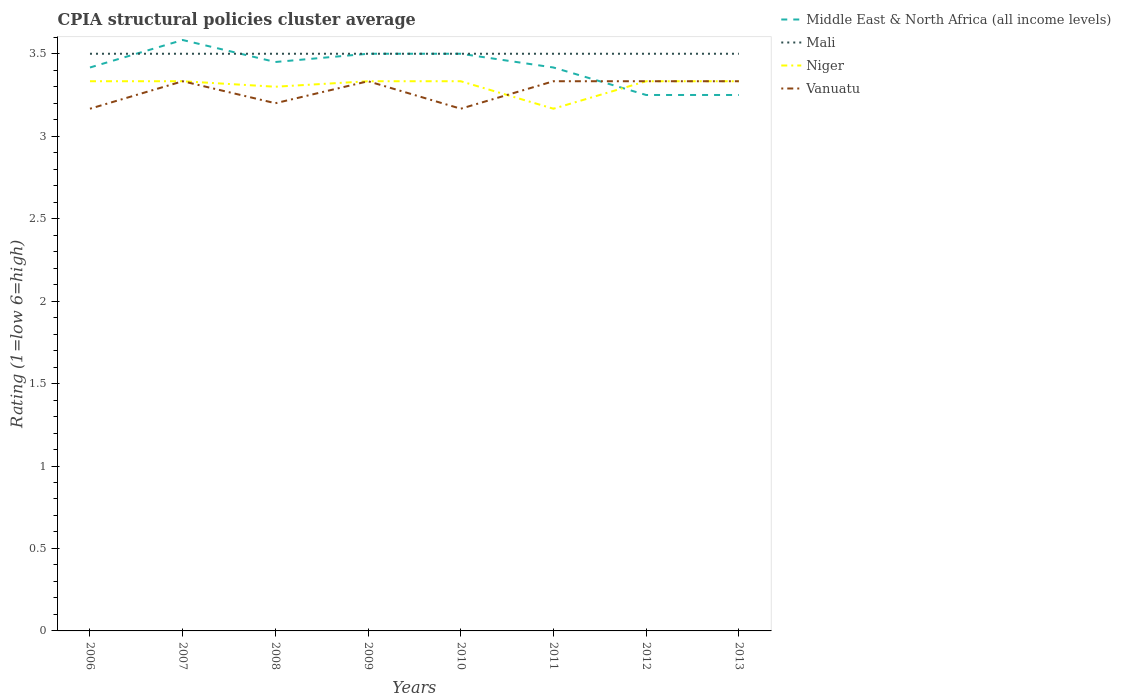How many different coloured lines are there?
Give a very brief answer. 4. Is the number of lines equal to the number of legend labels?
Make the answer very short. Yes. Across all years, what is the maximum CPIA rating in Mali?
Give a very brief answer. 3.5. What is the difference between the highest and the second highest CPIA rating in Mali?
Make the answer very short. 0. What is the difference between the highest and the lowest CPIA rating in Vanuatu?
Ensure brevity in your answer.  5. Is the CPIA rating in Niger strictly greater than the CPIA rating in Middle East & North Africa (all income levels) over the years?
Keep it short and to the point. No. How many years are there in the graph?
Provide a succinct answer. 8. What is the difference between two consecutive major ticks on the Y-axis?
Your answer should be compact. 0.5. Does the graph contain any zero values?
Provide a succinct answer. No. Where does the legend appear in the graph?
Your response must be concise. Top right. How are the legend labels stacked?
Make the answer very short. Vertical. What is the title of the graph?
Your response must be concise. CPIA structural policies cluster average. What is the label or title of the X-axis?
Provide a short and direct response. Years. What is the Rating (1=low 6=high) in Middle East & North Africa (all income levels) in 2006?
Offer a terse response. 3.42. What is the Rating (1=low 6=high) in Mali in 2006?
Give a very brief answer. 3.5. What is the Rating (1=low 6=high) in Niger in 2006?
Make the answer very short. 3.33. What is the Rating (1=low 6=high) in Vanuatu in 2006?
Your answer should be very brief. 3.17. What is the Rating (1=low 6=high) of Middle East & North Africa (all income levels) in 2007?
Offer a terse response. 3.58. What is the Rating (1=low 6=high) in Niger in 2007?
Your answer should be very brief. 3.33. What is the Rating (1=low 6=high) in Vanuatu in 2007?
Offer a very short reply. 3.33. What is the Rating (1=low 6=high) of Middle East & North Africa (all income levels) in 2008?
Provide a short and direct response. 3.45. What is the Rating (1=low 6=high) of Niger in 2009?
Offer a very short reply. 3.33. What is the Rating (1=low 6=high) in Vanuatu in 2009?
Your answer should be very brief. 3.33. What is the Rating (1=low 6=high) in Middle East & North Africa (all income levels) in 2010?
Give a very brief answer. 3.5. What is the Rating (1=low 6=high) of Niger in 2010?
Offer a terse response. 3.33. What is the Rating (1=low 6=high) of Vanuatu in 2010?
Provide a short and direct response. 3.17. What is the Rating (1=low 6=high) of Middle East & North Africa (all income levels) in 2011?
Your answer should be very brief. 3.42. What is the Rating (1=low 6=high) of Mali in 2011?
Ensure brevity in your answer.  3.5. What is the Rating (1=low 6=high) of Niger in 2011?
Your answer should be compact. 3.17. What is the Rating (1=low 6=high) of Vanuatu in 2011?
Make the answer very short. 3.33. What is the Rating (1=low 6=high) in Middle East & North Africa (all income levels) in 2012?
Your answer should be very brief. 3.25. What is the Rating (1=low 6=high) of Mali in 2012?
Ensure brevity in your answer.  3.5. What is the Rating (1=low 6=high) in Niger in 2012?
Your answer should be compact. 3.33. What is the Rating (1=low 6=high) in Vanuatu in 2012?
Your answer should be compact. 3.33. What is the Rating (1=low 6=high) in Middle East & North Africa (all income levels) in 2013?
Your answer should be very brief. 3.25. What is the Rating (1=low 6=high) in Niger in 2013?
Ensure brevity in your answer.  3.33. What is the Rating (1=low 6=high) of Vanuatu in 2013?
Keep it short and to the point. 3.33. Across all years, what is the maximum Rating (1=low 6=high) in Middle East & North Africa (all income levels)?
Ensure brevity in your answer.  3.58. Across all years, what is the maximum Rating (1=low 6=high) in Mali?
Your response must be concise. 3.5. Across all years, what is the maximum Rating (1=low 6=high) of Niger?
Give a very brief answer. 3.33. Across all years, what is the maximum Rating (1=low 6=high) of Vanuatu?
Ensure brevity in your answer.  3.33. Across all years, what is the minimum Rating (1=low 6=high) of Niger?
Make the answer very short. 3.17. Across all years, what is the minimum Rating (1=low 6=high) of Vanuatu?
Offer a very short reply. 3.17. What is the total Rating (1=low 6=high) of Middle East & North Africa (all income levels) in the graph?
Provide a succinct answer. 27.37. What is the total Rating (1=low 6=high) of Mali in the graph?
Your answer should be compact. 28. What is the total Rating (1=low 6=high) of Niger in the graph?
Your answer should be very brief. 26.47. What is the total Rating (1=low 6=high) in Vanuatu in the graph?
Keep it short and to the point. 26.2. What is the difference between the Rating (1=low 6=high) of Mali in 2006 and that in 2007?
Your answer should be very brief. 0. What is the difference between the Rating (1=low 6=high) in Niger in 2006 and that in 2007?
Offer a terse response. 0. What is the difference between the Rating (1=low 6=high) of Middle East & North Africa (all income levels) in 2006 and that in 2008?
Offer a terse response. -0.03. What is the difference between the Rating (1=low 6=high) in Mali in 2006 and that in 2008?
Your answer should be compact. 0. What is the difference between the Rating (1=low 6=high) in Vanuatu in 2006 and that in 2008?
Offer a very short reply. -0.03. What is the difference between the Rating (1=low 6=high) of Middle East & North Africa (all income levels) in 2006 and that in 2009?
Offer a terse response. -0.08. What is the difference between the Rating (1=low 6=high) in Mali in 2006 and that in 2009?
Provide a succinct answer. 0. What is the difference between the Rating (1=low 6=high) of Niger in 2006 and that in 2009?
Offer a terse response. 0. What is the difference between the Rating (1=low 6=high) in Middle East & North Africa (all income levels) in 2006 and that in 2010?
Offer a terse response. -0.08. What is the difference between the Rating (1=low 6=high) in Niger in 2006 and that in 2010?
Provide a short and direct response. 0. What is the difference between the Rating (1=low 6=high) of Middle East & North Africa (all income levels) in 2006 and that in 2011?
Make the answer very short. 0. What is the difference between the Rating (1=low 6=high) in Mali in 2006 and that in 2011?
Provide a succinct answer. 0. What is the difference between the Rating (1=low 6=high) of Middle East & North Africa (all income levels) in 2006 and that in 2012?
Your answer should be compact. 0.17. What is the difference between the Rating (1=low 6=high) in Niger in 2006 and that in 2013?
Provide a succinct answer. 0. What is the difference between the Rating (1=low 6=high) in Vanuatu in 2006 and that in 2013?
Offer a terse response. -0.17. What is the difference between the Rating (1=low 6=high) of Middle East & North Africa (all income levels) in 2007 and that in 2008?
Your response must be concise. 0.13. What is the difference between the Rating (1=low 6=high) in Vanuatu in 2007 and that in 2008?
Ensure brevity in your answer.  0.13. What is the difference between the Rating (1=low 6=high) in Middle East & North Africa (all income levels) in 2007 and that in 2009?
Give a very brief answer. 0.08. What is the difference between the Rating (1=low 6=high) of Mali in 2007 and that in 2009?
Provide a short and direct response. 0. What is the difference between the Rating (1=low 6=high) of Middle East & North Africa (all income levels) in 2007 and that in 2010?
Provide a short and direct response. 0.08. What is the difference between the Rating (1=low 6=high) in Vanuatu in 2007 and that in 2010?
Give a very brief answer. 0.17. What is the difference between the Rating (1=low 6=high) of Mali in 2007 and that in 2011?
Offer a terse response. 0. What is the difference between the Rating (1=low 6=high) of Vanuatu in 2007 and that in 2011?
Your answer should be very brief. 0. What is the difference between the Rating (1=low 6=high) in Vanuatu in 2007 and that in 2012?
Make the answer very short. 0. What is the difference between the Rating (1=low 6=high) in Mali in 2007 and that in 2013?
Ensure brevity in your answer.  0. What is the difference between the Rating (1=low 6=high) in Mali in 2008 and that in 2009?
Provide a short and direct response. 0. What is the difference between the Rating (1=low 6=high) in Niger in 2008 and that in 2009?
Provide a short and direct response. -0.03. What is the difference between the Rating (1=low 6=high) in Vanuatu in 2008 and that in 2009?
Give a very brief answer. -0.13. What is the difference between the Rating (1=low 6=high) of Middle East & North Africa (all income levels) in 2008 and that in 2010?
Offer a very short reply. -0.05. What is the difference between the Rating (1=low 6=high) of Niger in 2008 and that in 2010?
Provide a short and direct response. -0.03. What is the difference between the Rating (1=low 6=high) of Vanuatu in 2008 and that in 2010?
Provide a short and direct response. 0.03. What is the difference between the Rating (1=low 6=high) in Niger in 2008 and that in 2011?
Offer a terse response. 0.13. What is the difference between the Rating (1=low 6=high) of Vanuatu in 2008 and that in 2011?
Provide a succinct answer. -0.13. What is the difference between the Rating (1=low 6=high) in Niger in 2008 and that in 2012?
Your response must be concise. -0.03. What is the difference between the Rating (1=low 6=high) of Vanuatu in 2008 and that in 2012?
Make the answer very short. -0.13. What is the difference between the Rating (1=low 6=high) of Middle East & North Africa (all income levels) in 2008 and that in 2013?
Give a very brief answer. 0.2. What is the difference between the Rating (1=low 6=high) in Niger in 2008 and that in 2013?
Your answer should be very brief. -0.03. What is the difference between the Rating (1=low 6=high) in Vanuatu in 2008 and that in 2013?
Provide a short and direct response. -0.13. What is the difference between the Rating (1=low 6=high) of Middle East & North Africa (all income levels) in 2009 and that in 2010?
Offer a terse response. 0. What is the difference between the Rating (1=low 6=high) in Vanuatu in 2009 and that in 2010?
Give a very brief answer. 0.17. What is the difference between the Rating (1=low 6=high) of Middle East & North Africa (all income levels) in 2009 and that in 2011?
Provide a succinct answer. 0.08. What is the difference between the Rating (1=low 6=high) in Niger in 2009 and that in 2011?
Offer a very short reply. 0.17. What is the difference between the Rating (1=low 6=high) of Niger in 2009 and that in 2012?
Offer a terse response. 0. What is the difference between the Rating (1=low 6=high) of Mali in 2009 and that in 2013?
Keep it short and to the point. 0. What is the difference between the Rating (1=low 6=high) in Niger in 2009 and that in 2013?
Your answer should be very brief. 0. What is the difference between the Rating (1=low 6=high) in Middle East & North Africa (all income levels) in 2010 and that in 2011?
Make the answer very short. 0.08. What is the difference between the Rating (1=low 6=high) of Middle East & North Africa (all income levels) in 2010 and that in 2012?
Your answer should be compact. 0.25. What is the difference between the Rating (1=low 6=high) of Vanuatu in 2010 and that in 2012?
Your response must be concise. -0.17. What is the difference between the Rating (1=low 6=high) in Mali in 2010 and that in 2013?
Keep it short and to the point. 0. What is the difference between the Rating (1=low 6=high) in Niger in 2010 and that in 2013?
Make the answer very short. 0. What is the difference between the Rating (1=low 6=high) of Vanuatu in 2010 and that in 2013?
Make the answer very short. -0.17. What is the difference between the Rating (1=low 6=high) in Middle East & North Africa (all income levels) in 2011 and that in 2012?
Your response must be concise. 0.17. What is the difference between the Rating (1=low 6=high) of Niger in 2011 and that in 2012?
Provide a succinct answer. -0.17. What is the difference between the Rating (1=low 6=high) of Middle East & North Africa (all income levels) in 2011 and that in 2013?
Your response must be concise. 0.17. What is the difference between the Rating (1=low 6=high) in Mali in 2011 and that in 2013?
Make the answer very short. 0. What is the difference between the Rating (1=low 6=high) of Niger in 2011 and that in 2013?
Your answer should be compact. -0.17. What is the difference between the Rating (1=low 6=high) in Vanuatu in 2011 and that in 2013?
Ensure brevity in your answer.  0. What is the difference between the Rating (1=low 6=high) of Vanuatu in 2012 and that in 2013?
Make the answer very short. 0. What is the difference between the Rating (1=low 6=high) of Middle East & North Africa (all income levels) in 2006 and the Rating (1=low 6=high) of Mali in 2007?
Provide a succinct answer. -0.08. What is the difference between the Rating (1=low 6=high) of Middle East & North Africa (all income levels) in 2006 and the Rating (1=low 6=high) of Niger in 2007?
Give a very brief answer. 0.08. What is the difference between the Rating (1=low 6=high) of Middle East & North Africa (all income levels) in 2006 and the Rating (1=low 6=high) of Vanuatu in 2007?
Your response must be concise. 0.08. What is the difference between the Rating (1=low 6=high) of Middle East & North Africa (all income levels) in 2006 and the Rating (1=low 6=high) of Mali in 2008?
Keep it short and to the point. -0.08. What is the difference between the Rating (1=low 6=high) of Middle East & North Africa (all income levels) in 2006 and the Rating (1=low 6=high) of Niger in 2008?
Offer a terse response. 0.12. What is the difference between the Rating (1=low 6=high) in Middle East & North Africa (all income levels) in 2006 and the Rating (1=low 6=high) in Vanuatu in 2008?
Ensure brevity in your answer.  0.22. What is the difference between the Rating (1=low 6=high) in Mali in 2006 and the Rating (1=low 6=high) in Niger in 2008?
Make the answer very short. 0.2. What is the difference between the Rating (1=low 6=high) of Mali in 2006 and the Rating (1=low 6=high) of Vanuatu in 2008?
Keep it short and to the point. 0.3. What is the difference between the Rating (1=low 6=high) of Niger in 2006 and the Rating (1=low 6=high) of Vanuatu in 2008?
Keep it short and to the point. 0.13. What is the difference between the Rating (1=low 6=high) in Middle East & North Africa (all income levels) in 2006 and the Rating (1=low 6=high) in Mali in 2009?
Your answer should be very brief. -0.08. What is the difference between the Rating (1=low 6=high) of Middle East & North Africa (all income levels) in 2006 and the Rating (1=low 6=high) of Niger in 2009?
Provide a short and direct response. 0.08. What is the difference between the Rating (1=low 6=high) of Middle East & North Africa (all income levels) in 2006 and the Rating (1=low 6=high) of Vanuatu in 2009?
Your answer should be very brief. 0.08. What is the difference between the Rating (1=low 6=high) of Mali in 2006 and the Rating (1=low 6=high) of Niger in 2009?
Provide a succinct answer. 0.17. What is the difference between the Rating (1=low 6=high) in Middle East & North Africa (all income levels) in 2006 and the Rating (1=low 6=high) in Mali in 2010?
Offer a terse response. -0.08. What is the difference between the Rating (1=low 6=high) in Middle East & North Africa (all income levels) in 2006 and the Rating (1=low 6=high) in Niger in 2010?
Ensure brevity in your answer.  0.08. What is the difference between the Rating (1=low 6=high) in Mali in 2006 and the Rating (1=low 6=high) in Niger in 2010?
Ensure brevity in your answer.  0.17. What is the difference between the Rating (1=low 6=high) in Mali in 2006 and the Rating (1=low 6=high) in Vanuatu in 2010?
Keep it short and to the point. 0.33. What is the difference between the Rating (1=low 6=high) of Middle East & North Africa (all income levels) in 2006 and the Rating (1=low 6=high) of Mali in 2011?
Offer a terse response. -0.08. What is the difference between the Rating (1=low 6=high) of Middle East & North Africa (all income levels) in 2006 and the Rating (1=low 6=high) of Niger in 2011?
Give a very brief answer. 0.25. What is the difference between the Rating (1=low 6=high) of Middle East & North Africa (all income levels) in 2006 and the Rating (1=low 6=high) of Vanuatu in 2011?
Offer a very short reply. 0.08. What is the difference between the Rating (1=low 6=high) in Mali in 2006 and the Rating (1=low 6=high) in Vanuatu in 2011?
Make the answer very short. 0.17. What is the difference between the Rating (1=low 6=high) of Niger in 2006 and the Rating (1=low 6=high) of Vanuatu in 2011?
Your answer should be very brief. 0. What is the difference between the Rating (1=low 6=high) in Middle East & North Africa (all income levels) in 2006 and the Rating (1=low 6=high) in Mali in 2012?
Provide a short and direct response. -0.08. What is the difference between the Rating (1=low 6=high) of Middle East & North Africa (all income levels) in 2006 and the Rating (1=low 6=high) of Niger in 2012?
Your answer should be compact. 0.08. What is the difference between the Rating (1=low 6=high) in Middle East & North Africa (all income levels) in 2006 and the Rating (1=low 6=high) in Vanuatu in 2012?
Your answer should be compact. 0.08. What is the difference between the Rating (1=low 6=high) in Mali in 2006 and the Rating (1=low 6=high) in Niger in 2012?
Make the answer very short. 0.17. What is the difference between the Rating (1=low 6=high) in Mali in 2006 and the Rating (1=low 6=high) in Vanuatu in 2012?
Offer a very short reply. 0.17. What is the difference between the Rating (1=low 6=high) in Niger in 2006 and the Rating (1=low 6=high) in Vanuatu in 2012?
Provide a short and direct response. 0. What is the difference between the Rating (1=low 6=high) of Middle East & North Africa (all income levels) in 2006 and the Rating (1=low 6=high) of Mali in 2013?
Your response must be concise. -0.08. What is the difference between the Rating (1=low 6=high) in Middle East & North Africa (all income levels) in 2006 and the Rating (1=low 6=high) in Niger in 2013?
Your response must be concise. 0.08. What is the difference between the Rating (1=low 6=high) in Middle East & North Africa (all income levels) in 2006 and the Rating (1=low 6=high) in Vanuatu in 2013?
Provide a short and direct response. 0.08. What is the difference between the Rating (1=low 6=high) in Niger in 2006 and the Rating (1=low 6=high) in Vanuatu in 2013?
Make the answer very short. 0. What is the difference between the Rating (1=low 6=high) of Middle East & North Africa (all income levels) in 2007 and the Rating (1=low 6=high) of Mali in 2008?
Keep it short and to the point. 0.08. What is the difference between the Rating (1=low 6=high) in Middle East & North Africa (all income levels) in 2007 and the Rating (1=low 6=high) in Niger in 2008?
Provide a succinct answer. 0.28. What is the difference between the Rating (1=low 6=high) of Middle East & North Africa (all income levels) in 2007 and the Rating (1=low 6=high) of Vanuatu in 2008?
Provide a short and direct response. 0.38. What is the difference between the Rating (1=low 6=high) of Mali in 2007 and the Rating (1=low 6=high) of Niger in 2008?
Your answer should be compact. 0.2. What is the difference between the Rating (1=low 6=high) of Niger in 2007 and the Rating (1=low 6=high) of Vanuatu in 2008?
Your answer should be compact. 0.13. What is the difference between the Rating (1=low 6=high) in Middle East & North Africa (all income levels) in 2007 and the Rating (1=low 6=high) in Mali in 2009?
Ensure brevity in your answer.  0.08. What is the difference between the Rating (1=low 6=high) in Niger in 2007 and the Rating (1=low 6=high) in Vanuatu in 2009?
Keep it short and to the point. 0. What is the difference between the Rating (1=low 6=high) in Middle East & North Africa (all income levels) in 2007 and the Rating (1=low 6=high) in Mali in 2010?
Make the answer very short. 0.08. What is the difference between the Rating (1=low 6=high) of Middle East & North Africa (all income levels) in 2007 and the Rating (1=low 6=high) of Vanuatu in 2010?
Keep it short and to the point. 0.42. What is the difference between the Rating (1=low 6=high) in Mali in 2007 and the Rating (1=low 6=high) in Niger in 2010?
Your answer should be very brief. 0.17. What is the difference between the Rating (1=low 6=high) of Mali in 2007 and the Rating (1=low 6=high) of Vanuatu in 2010?
Offer a very short reply. 0.33. What is the difference between the Rating (1=low 6=high) of Niger in 2007 and the Rating (1=low 6=high) of Vanuatu in 2010?
Your answer should be very brief. 0.17. What is the difference between the Rating (1=low 6=high) of Middle East & North Africa (all income levels) in 2007 and the Rating (1=low 6=high) of Mali in 2011?
Keep it short and to the point. 0.08. What is the difference between the Rating (1=low 6=high) in Middle East & North Africa (all income levels) in 2007 and the Rating (1=low 6=high) in Niger in 2011?
Your answer should be very brief. 0.42. What is the difference between the Rating (1=low 6=high) of Mali in 2007 and the Rating (1=low 6=high) of Niger in 2011?
Your answer should be compact. 0.33. What is the difference between the Rating (1=low 6=high) of Niger in 2007 and the Rating (1=low 6=high) of Vanuatu in 2011?
Make the answer very short. 0. What is the difference between the Rating (1=low 6=high) of Middle East & North Africa (all income levels) in 2007 and the Rating (1=low 6=high) of Mali in 2012?
Your response must be concise. 0.08. What is the difference between the Rating (1=low 6=high) of Mali in 2007 and the Rating (1=low 6=high) of Vanuatu in 2012?
Provide a succinct answer. 0.17. What is the difference between the Rating (1=low 6=high) in Niger in 2007 and the Rating (1=low 6=high) in Vanuatu in 2012?
Provide a short and direct response. 0. What is the difference between the Rating (1=low 6=high) of Middle East & North Africa (all income levels) in 2007 and the Rating (1=low 6=high) of Mali in 2013?
Your answer should be very brief. 0.08. What is the difference between the Rating (1=low 6=high) in Middle East & North Africa (all income levels) in 2007 and the Rating (1=low 6=high) in Vanuatu in 2013?
Offer a very short reply. 0.25. What is the difference between the Rating (1=low 6=high) in Mali in 2007 and the Rating (1=low 6=high) in Vanuatu in 2013?
Make the answer very short. 0.17. What is the difference between the Rating (1=low 6=high) of Niger in 2007 and the Rating (1=low 6=high) of Vanuatu in 2013?
Make the answer very short. 0. What is the difference between the Rating (1=low 6=high) in Middle East & North Africa (all income levels) in 2008 and the Rating (1=low 6=high) in Niger in 2009?
Make the answer very short. 0.12. What is the difference between the Rating (1=low 6=high) in Middle East & North Africa (all income levels) in 2008 and the Rating (1=low 6=high) in Vanuatu in 2009?
Keep it short and to the point. 0.12. What is the difference between the Rating (1=low 6=high) in Niger in 2008 and the Rating (1=low 6=high) in Vanuatu in 2009?
Make the answer very short. -0.03. What is the difference between the Rating (1=low 6=high) in Middle East & North Africa (all income levels) in 2008 and the Rating (1=low 6=high) in Mali in 2010?
Give a very brief answer. -0.05. What is the difference between the Rating (1=low 6=high) in Middle East & North Africa (all income levels) in 2008 and the Rating (1=low 6=high) in Niger in 2010?
Make the answer very short. 0.12. What is the difference between the Rating (1=low 6=high) of Middle East & North Africa (all income levels) in 2008 and the Rating (1=low 6=high) of Vanuatu in 2010?
Provide a succinct answer. 0.28. What is the difference between the Rating (1=low 6=high) of Niger in 2008 and the Rating (1=low 6=high) of Vanuatu in 2010?
Offer a very short reply. 0.13. What is the difference between the Rating (1=low 6=high) of Middle East & North Africa (all income levels) in 2008 and the Rating (1=low 6=high) of Mali in 2011?
Your answer should be very brief. -0.05. What is the difference between the Rating (1=low 6=high) in Middle East & North Africa (all income levels) in 2008 and the Rating (1=low 6=high) in Niger in 2011?
Provide a short and direct response. 0.28. What is the difference between the Rating (1=low 6=high) in Middle East & North Africa (all income levels) in 2008 and the Rating (1=low 6=high) in Vanuatu in 2011?
Your response must be concise. 0.12. What is the difference between the Rating (1=low 6=high) in Mali in 2008 and the Rating (1=low 6=high) in Niger in 2011?
Ensure brevity in your answer.  0.33. What is the difference between the Rating (1=low 6=high) of Niger in 2008 and the Rating (1=low 6=high) of Vanuatu in 2011?
Provide a succinct answer. -0.03. What is the difference between the Rating (1=low 6=high) of Middle East & North Africa (all income levels) in 2008 and the Rating (1=low 6=high) of Niger in 2012?
Your answer should be very brief. 0.12. What is the difference between the Rating (1=low 6=high) in Middle East & North Africa (all income levels) in 2008 and the Rating (1=low 6=high) in Vanuatu in 2012?
Ensure brevity in your answer.  0.12. What is the difference between the Rating (1=low 6=high) in Mali in 2008 and the Rating (1=low 6=high) in Niger in 2012?
Ensure brevity in your answer.  0.17. What is the difference between the Rating (1=low 6=high) of Mali in 2008 and the Rating (1=low 6=high) of Vanuatu in 2012?
Keep it short and to the point. 0.17. What is the difference between the Rating (1=low 6=high) in Niger in 2008 and the Rating (1=low 6=high) in Vanuatu in 2012?
Your answer should be very brief. -0.03. What is the difference between the Rating (1=low 6=high) in Middle East & North Africa (all income levels) in 2008 and the Rating (1=low 6=high) in Mali in 2013?
Offer a terse response. -0.05. What is the difference between the Rating (1=low 6=high) in Middle East & North Africa (all income levels) in 2008 and the Rating (1=low 6=high) in Niger in 2013?
Ensure brevity in your answer.  0.12. What is the difference between the Rating (1=low 6=high) of Middle East & North Africa (all income levels) in 2008 and the Rating (1=low 6=high) of Vanuatu in 2013?
Make the answer very short. 0.12. What is the difference between the Rating (1=low 6=high) of Niger in 2008 and the Rating (1=low 6=high) of Vanuatu in 2013?
Offer a terse response. -0.03. What is the difference between the Rating (1=low 6=high) in Mali in 2009 and the Rating (1=low 6=high) in Vanuatu in 2010?
Keep it short and to the point. 0.33. What is the difference between the Rating (1=low 6=high) of Middle East & North Africa (all income levels) in 2009 and the Rating (1=low 6=high) of Mali in 2011?
Offer a terse response. 0. What is the difference between the Rating (1=low 6=high) in Middle East & North Africa (all income levels) in 2009 and the Rating (1=low 6=high) in Vanuatu in 2011?
Ensure brevity in your answer.  0.17. What is the difference between the Rating (1=low 6=high) in Mali in 2009 and the Rating (1=low 6=high) in Vanuatu in 2011?
Make the answer very short. 0.17. What is the difference between the Rating (1=low 6=high) in Niger in 2009 and the Rating (1=low 6=high) in Vanuatu in 2011?
Give a very brief answer. 0. What is the difference between the Rating (1=low 6=high) of Middle East & North Africa (all income levels) in 2009 and the Rating (1=low 6=high) of Mali in 2012?
Your response must be concise. 0. What is the difference between the Rating (1=low 6=high) of Middle East & North Africa (all income levels) in 2009 and the Rating (1=low 6=high) of Vanuatu in 2012?
Offer a very short reply. 0.17. What is the difference between the Rating (1=low 6=high) in Mali in 2009 and the Rating (1=low 6=high) in Niger in 2012?
Provide a short and direct response. 0.17. What is the difference between the Rating (1=low 6=high) in Middle East & North Africa (all income levels) in 2009 and the Rating (1=low 6=high) in Vanuatu in 2013?
Provide a short and direct response. 0.17. What is the difference between the Rating (1=low 6=high) of Mali in 2009 and the Rating (1=low 6=high) of Niger in 2013?
Provide a short and direct response. 0.17. What is the difference between the Rating (1=low 6=high) of Middle East & North Africa (all income levels) in 2010 and the Rating (1=low 6=high) of Niger in 2011?
Provide a succinct answer. 0.33. What is the difference between the Rating (1=low 6=high) of Middle East & North Africa (all income levels) in 2010 and the Rating (1=low 6=high) of Vanuatu in 2011?
Provide a short and direct response. 0.17. What is the difference between the Rating (1=low 6=high) in Mali in 2010 and the Rating (1=low 6=high) in Vanuatu in 2011?
Provide a short and direct response. 0.17. What is the difference between the Rating (1=low 6=high) of Middle East & North Africa (all income levels) in 2010 and the Rating (1=low 6=high) of Mali in 2012?
Keep it short and to the point. 0. What is the difference between the Rating (1=low 6=high) in Niger in 2010 and the Rating (1=low 6=high) in Vanuatu in 2012?
Ensure brevity in your answer.  0. What is the difference between the Rating (1=low 6=high) in Middle East & North Africa (all income levels) in 2010 and the Rating (1=low 6=high) in Niger in 2013?
Ensure brevity in your answer.  0.17. What is the difference between the Rating (1=low 6=high) in Middle East & North Africa (all income levels) in 2010 and the Rating (1=low 6=high) in Vanuatu in 2013?
Offer a terse response. 0.17. What is the difference between the Rating (1=low 6=high) in Mali in 2010 and the Rating (1=low 6=high) in Niger in 2013?
Provide a succinct answer. 0.17. What is the difference between the Rating (1=low 6=high) of Mali in 2010 and the Rating (1=low 6=high) of Vanuatu in 2013?
Your response must be concise. 0.17. What is the difference between the Rating (1=low 6=high) in Middle East & North Africa (all income levels) in 2011 and the Rating (1=low 6=high) in Mali in 2012?
Offer a terse response. -0.08. What is the difference between the Rating (1=low 6=high) of Middle East & North Africa (all income levels) in 2011 and the Rating (1=low 6=high) of Niger in 2012?
Your response must be concise. 0.08. What is the difference between the Rating (1=low 6=high) in Middle East & North Africa (all income levels) in 2011 and the Rating (1=low 6=high) in Vanuatu in 2012?
Give a very brief answer. 0.08. What is the difference between the Rating (1=low 6=high) in Mali in 2011 and the Rating (1=low 6=high) in Niger in 2012?
Provide a short and direct response. 0.17. What is the difference between the Rating (1=low 6=high) of Niger in 2011 and the Rating (1=low 6=high) of Vanuatu in 2012?
Keep it short and to the point. -0.17. What is the difference between the Rating (1=low 6=high) in Middle East & North Africa (all income levels) in 2011 and the Rating (1=low 6=high) in Mali in 2013?
Provide a succinct answer. -0.08. What is the difference between the Rating (1=low 6=high) of Middle East & North Africa (all income levels) in 2011 and the Rating (1=low 6=high) of Niger in 2013?
Your answer should be compact. 0.08. What is the difference between the Rating (1=low 6=high) in Middle East & North Africa (all income levels) in 2011 and the Rating (1=low 6=high) in Vanuatu in 2013?
Offer a terse response. 0.08. What is the difference between the Rating (1=low 6=high) in Mali in 2011 and the Rating (1=low 6=high) in Niger in 2013?
Provide a short and direct response. 0.17. What is the difference between the Rating (1=low 6=high) in Niger in 2011 and the Rating (1=low 6=high) in Vanuatu in 2013?
Your response must be concise. -0.17. What is the difference between the Rating (1=low 6=high) of Middle East & North Africa (all income levels) in 2012 and the Rating (1=low 6=high) of Niger in 2013?
Give a very brief answer. -0.08. What is the difference between the Rating (1=low 6=high) of Middle East & North Africa (all income levels) in 2012 and the Rating (1=low 6=high) of Vanuatu in 2013?
Your answer should be compact. -0.08. What is the average Rating (1=low 6=high) of Middle East & North Africa (all income levels) per year?
Offer a very short reply. 3.42. What is the average Rating (1=low 6=high) in Mali per year?
Keep it short and to the point. 3.5. What is the average Rating (1=low 6=high) of Niger per year?
Your answer should be very brief. 3.31. What is the average Rating (1=low 6=high) of Vanuatu per year?
Offer a terse response. 3.27. In the year 2006, what is the difference between the Rating (1=low 6=high) in Middle East & North Africa (all income levels) and Rating (1=low 6=high) in Mali?
Provide a short and direct response. -0.08. In the year 2006, what is the difference between the Rating (1=low 6=high) of Middle East & North Africa (all income levels) and Rating (1=low 6=high) of Niger?
Provide a succinct answer. 0.08. In the year 2006, what is the difference between the Rating (1=low 6=high) in Niger and Rating (1=low 6=high) in Vanuatu?
Your answer should be very brief. 0.17. In the year 2007, what is the difference between the Rating (1=low 6=high) of Middle East & North Africa (all income levels) and Rating (1=low 6=high) of Mali?
Keep it short and to the point. 0.08. In the year 2008, what is the difference between the Rating (1=low 6=high) in Middle East & North Africa (all income levels) and Rating (1=low 6=high) in Niger?
Your answer should be very brief. 0.15. In the year 2008, what is the difference between the Rating (1=low 6=high) of Middle East & North Africa (all income levels) and Rating (1=low 6=high) of Vanuatu?
Offer a very short reply. 0.25. In the year 2008, what is the difference between the Rating (1=low 6=high) in Mali and Rating (1=low 6=high) in Vanuatu?
Your answer should be compact. 0.3. In the year 2008, what is the difference between the Rating (1=low 6=high) in Niger and Rating (1=low 6=high) in Vanuatu?
Make the answer very short. 0.1. In the year 2009, what is the difference between the Rating (1=low 6=high) of Middle East & North Africa (all income levels) and Rating (1=low 6=high) of Vanuatu?
Ensure brevity in your answer.  0.17. In the year 2009, what is the difference between the Rating (1=low 6=high) of Niger and Rating (1=low 6=high) of Vanuatu?
Provide a short and direct response. 0. In the year 2010, what is the difference between the Rating (1=low 6=high) in Niger and Rating (1=low 6=high) in Vanuatu?
Offer a very short reply. 0.17. In the year 2011, what is the difference between the Rating (1=low 6=high) of Middle East & North Africa (all income levels) and Rating (1=low 6=high) of Mali?
Your answer should be compact. -0.08. In the year 2011, what is the difference between the Rating (1=low 6=high) in Middle East & North Africa (all income levels) and Rating (1=low 6=high) in Vanuatu?
Your response must be concise. 0.08. In the year 2011, what is the difference between the Rating (1=low 6=high) of Mali and Rating (1=low 6=high) of Niger?
Your response must be concise. 0.33. In the year 2011, what is the difference between the Rating (1=low 6=high) in Mali and Rating (1=low 6=high) in Vanuatu?
Provide a succinct answer. 0.17. In the year 2011, what is the difference between the Rating (1=low 6=high) of Niger and Rating (1=low 6=high) of Vanuatu?
Provide a succinct answer. -0.17. In the year 2012, what is the difference between the Rating (1=low 6=high) of Middle East & North Africa (all income levels) and Rating (1=low 6=high) of Niger?
Offer a very short reply. -0.08. In the year 2012, what is the difference between the Rating (1=low 6=high) in Middle East & North Africa (all income levels) and Rating (1=low 6=high) in Vanuatu?
Offer a very short reply. -0.08. In the year 2012, what is the difference between the Rating (1=low 6=high) in Mali and Rating (1=low 6=high) in Niger?
Give a very brief answer. 0.17. In the year 2013, what is the difference between the Rating (1=low 6=high) of Middle East & North Africa (all income levels) and Rating (1=low 6=high) of Niger?
Provide a short and direct response. -0.08. In the year 2013, what is the difference between the Rating (1=low 6=high) of Middle East & North Africa (all income levels) and Rating (1=low 6=high) of Vanuatu?
Your response must be concise. -0.08. In the year 2013, what is the difference between the Rating (1=low 6=high) of Mali and Rating (1=low 6=high) of Niger?
Keep it short and to the point. 0.17. In the year 2013, what is the difference between the Rating (1=low 6=high) of Mali and Rating (1=low 6=high) of Vanuatu?
Your answer should be compact. 0.17. What is the ratio of the Rating (1=low 6=high) in Middle East & North Africa (all income levels) in 2006 to that in 2007?
Ensure brevity in your answer.  0.95. What is the ratio of the Rating (1=low 6=high) in Middle East & North Africa (all income levels) in 2006 to that in 2008?
Give a very brief answer. 0.99. What is the ratio of the Rating (1=low 6=high) of Middle East & North Africa (all income levels) in 2006 to that in 2009?
Keep it short and to the point. 0.98. What is the ratio of the Rating (1=low 6=high) of Mali in 2006 to that in 2009?
Keep it short and to the point. 1. What is the ratio of the Rating (1=low 6=high) of Niger in 2006 to that in 2009?
Your answer should be compact. 1. What is the ratio of the Rating (1=low 6=high) of Middle East & North Africa (all income levels) in 2006 to that in 2010?
Ensure brevity in your answer.  0.98. What is the ratio of the Rating (1=low 6=high) in Niger in 2006 to that in 2010?
Provide a short and direct response. 1. What is the ratio of the Rating (1=low 6=high) in Mali in 2006 to that in 2011?
Make the answer very short. 1. What is the ratio of the Rating (1=low 6=high) of Niger in 2006 to that in 2011?
Give a very brief answer. 1.05. What is the ratio of the Rating (1=low 6=high) of Vanuatu in 2006 to that in 2011?
Provide a short and direct response. 0.95. What is the ratio of the Rating (1=low 6=high) in Middle East & North Africa (all income levels) in 2006 to that in 2012?
Make the answer very short. 1.05. What is the ratio of the Rating (1=low 6=high) of Mali in 2006 to that in 2012?
Provide a short and direct response. 1. What is the ratio of the Rating (1=low 6=high) of Niger in 2006 to that in 2012?
Your response must be concise. 1. What is the ratio of the Rating (1=low 6=high) of Middle East & North Africa (all income levels) in 2006 to that in 2013?
Offer a terse response. 1.05. What is the ratio of the Rating (1=low 6=high) in Middle East & North Africa (all income levels) in 2007 to that in 2008?
Give a very brief answer. 1.04. What is the ratio of the Rating (1=low 6=high) in Mali in 2007 to that in 2008?
Give a very brief answer. 1. What is the ratio of the Rating (1=low 6=high) of Niger in 2007 to that in 2008?
Ensure brevity in your answer.  1.01. What is the ratio of the Rating (1=low 6=high) of Vanuatu in 2007 to that in 2008?
Offer a very short reply. 1.04. What is the ratio of the Rating (1=low 6=high) of Middle East & North Africa (all income levels) in 2007 to that in 2009?
Make the answer very short. 1.02. What is the ratio of the Rating (1=low 6=high) of Middle East & North Africa (all income levels) in 2007 to that in 2010?
Offer a terse response. 1.02. What is the ratio of the Rating (1=low 6=high) in Niger in 2007 to that in 2010?
Make the answer very short. 1. What is the ratio of the Rating (1=low 6=high) of Vanuatu in 2007 to that in 2010?
Keep it short and to the point. 1.05. What is the ratio of the Rating (1=low 6=high) in Middle East & North Africa (all income levels) in 2007 to that in 2011?
Keep it short and to the point. 1.05. What is the ratio of the Rating (1=low 6=high) of Niger in 2007 to that in 2011?
Give a very brief answer. 1.05. What is the ratio of the Rating (1=low 6=high) in Middle East & North Africa (all income levels) in 2007 to that in 2012?
Your answer should be very brief. 1.1. What is the ratio of the Rating (1=low 6=high) in Mali in 2007 to that in 2012?
Give a very brief answer. 1. What is the ratio of the Rating (1=low 6=high) in Vanuatu in 2007 to that in 2012?
Make the answer very short. 1. What is the ratio of the Rating (1=low 6=high) in Middle East & North Africa (all income levels) in 2007 to that in 2013?
Give a very brief answer. 1.1. What is the ratio of the Rating (1=low 6=high) in Mali in 2007 to that in 2013?
Your answer should be compact. 1. What is the ratio of the Rating (1=low 6=high) in Niger in 2007 to that in 2013?
Give a very brief answer. 1. What is the ratio of the Rating (1=low 6=high) of Vanuatu in 2007 to that in 2013?
Provide a short and direct response. 1. What is the ratio of the Rating (1=low 6=high) in Middle East & North Africa (all income levels) in 2008 to that in 2009?
Your answer should be compact. 0.99. What is the ratio of the Rating (1=low 6=high) in Vanuatu in 2008 to that in 2009?
Provide a short and direct response. 0.96. What is the ratio of the Rating (1=low 6=high) in Middle East & North Africa (all income levels) in 2008 to that in 2010?
Your answer should be compact. 0.99. What is the ratio of the Rating (1=low 6=high) in Vanuatu in 2008 to that in 2010?
Your response must be concise. 1.01. What is the ratio of the Rating (1=low 6=high) of Middle East & North Africa (all income levels) in 2008 to that in 2011?
Ensure brevity in your answer.  1.01. What is the ratio of the Rating (1=low 6=high) of Mali in 2008 to that in 2011?
Make the answer very short. 1. What is the ratio of the Rating (1=low 6=high) in Niger in 2008 to that in 2011?
Offer a very short reply. 1.04. What is the ratio of the Rating (1=low 6=high) of Vanuatu in 2008 to that in 2011?
Offer a very short reply. 0.96. What is the ratio of the Rating (1=low 6=high) of Middle East & North Africa (all income levels) in 2008 to that in 2012?
Offer a very short reply. 1.06. What is the ratio of the Rating (1=low 6=high) in Niger in 2008 to that in 2012?
Offer a very short reply. 0.99. What is the ratio of the Rating (1=low 6=high) in Vanuatu in 2008 to that in 2012?
Ensure brevity in your answer.  0.96. What is the ratio of the Rating (1=low 6=high) of Middle East & North Africa (all income levels) in 2008 to that in 2013?
Ensure brevity in your answer.  1.06. What is the ratio of the Rating (1=low 6=high) of Middle East & North Africa (all income levels) in 2009 to that in 2010?
Keep it short and to the point. 1. What is the ratio of the Rating (1=low 6=high) of Niger in 2009 to that in 2010?
Offer a very short reply. 1. What is the ratio of the Rating (1=low 6=high) in Vanuatu in 2009 to that in 2010?
Provide a short and direct response. 1.05. What is the ratio of the Rating (1=low 6=high) in Middle East & North Africa (all income levels) in 2009 to that in 2011?
Keep it short and to the point. 1.02. What is the ratio of the Rating (1=low 6=high) of Niger in 2009 to that in 2011?
Your response must be concise. 1.05. What is the ratio of the Rating (1=low 6=high) of Middle East & North Africa (all income levels) in 2009 to that in 2012?
Ensure brevity in your answer.  1.08. What is the ratio of the Rating (1=low 6=high) of Vanuatu in 2009 to that in 2012?
Your answer should be very brief. 1. What is the ratio of the Rating (1=low 6=high) in Mali in 2009 to that in 2013?
Offer a very short reply. 1. What is the ratio of the Rating (1=low 6=high) in Middle East & North Africa (all income levels) in 2010 to that in 2011?
Ensure brevity in your answer.  1.02. What is the ratio of the Rating (1=low 6=high) of Mali in 2010 to that in 2011?
Ensure brevity in your answer.  1. What is the ratio of the Rating (1=low 6=high) of Niger in 2010 to that in 2011?
Offer a very short reply. 1.05. What is the ratio of the Rating (1=low 6=high) in Middle East & North Africa (all income levels) in 2010 to that in 2012?
Offer a very short reply. 1.08. What is the ratio of the Rating (1=low 6=high) in Niger in 2010 to that in 2012?
Ensure brevity in your answer.  1. What is the ratio of the Rating (1=low 6=high) of Vanuatu in 2010 to that in 2012?
Your response must be concise. 0.95. What is the ratio of the Rating (1=low 6=high) in Mali in 2010 to that in 2013?
Make the answer very short. 1. What is the ratio of the Rating (1=low 6=high) of Niger in 2010 to that in 2013?
Give a very brief answer. 1. What is the ratio of the Rating (1=low 6=high) of Vanuatu in 2010 to that in 2013?
Provide a succinct answer. 0.95. What is the ratio of the Rating (1=low 6=high) in Middle East & North Africa (all income levels) in 2011 to that in 2012?
Your answer should be compact. 1.05. What is the ratio of the Rating (1=low 6=high) of Vanuatu in 2011 to that in 2012?
Your response must be concise. 1. What is the ratio of the Rating (1=low 6=high) in Middle East & North Africa (all income levels) in 2011 to that in 2013?
Ensure brevity in your answer.  1.05. What is the ratio of the Rating (1=low 6=high) of Mali in 2012 to that in 2013?
Offer a terse response. 1. What is the ratio of the Rating (1=low 6=high) of Niger in 2012 to that in 2013?
Your answer should be very brief. 1. What is the ratio of the Rating (1=low 6=high) in Vanuatu in 2012 to that in 2013?
Keep it short and to the point. 1. What is the difference between the highest and the second highest Rating (1=low 6=high) in Middle East & North Africa (all income levels)?
Provide a short and direct response. 0.08. What is the difference between the highest and the second highest Rating (1=low 6=high) of Vanuatu?
Provide a short and direct response. 0. What is the difference between the highest and the lowest Rating (1=low 6=high) in Middle East & North Africa (all income levels)?
Ensure brevity in your answer.  0.33. 